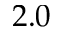Convert formula to latex. <formula><loc_0><loc_0><loc_500><loc_500>2 . 0</formula> 